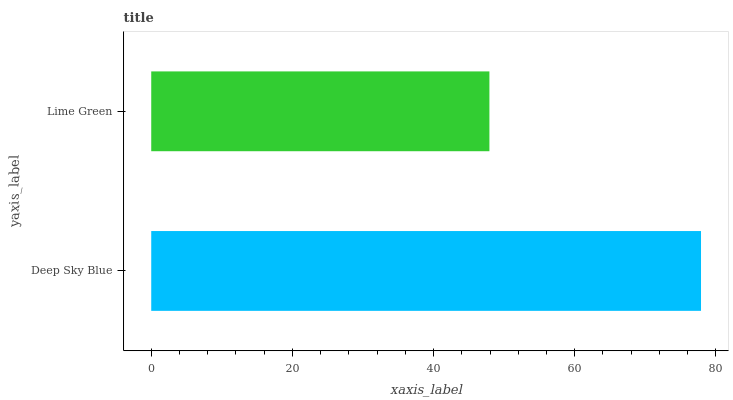Is Lime Green the minimum?
Answer yes or no. Yes. Is Deep Sky Blue the maximum?
Answer yes or no. Yes. Is Lime Green the maximum?
Answer yes or no. No. Is Deep Sky Blue greater than Lime Green?
Answer yes or no. Yes. Is Lime Green less than Deep Sky Blue?
Answer yes or no. Yes. Is Lime Green greater than Deep Sky Blue?
Answer yes or no. No. Is Deep Sky Blue less than Lime Green?
Answer yes or no. No. Is Deep Sky Blue the high median?
Answer yes or no. Yes. Is Lime Green the low median?
Answer yes or no. Yes. Is Lime Green the high median?
Answer yes or no. No. Is Deep Sky Blue the low median?
Answer yes or no. No. 